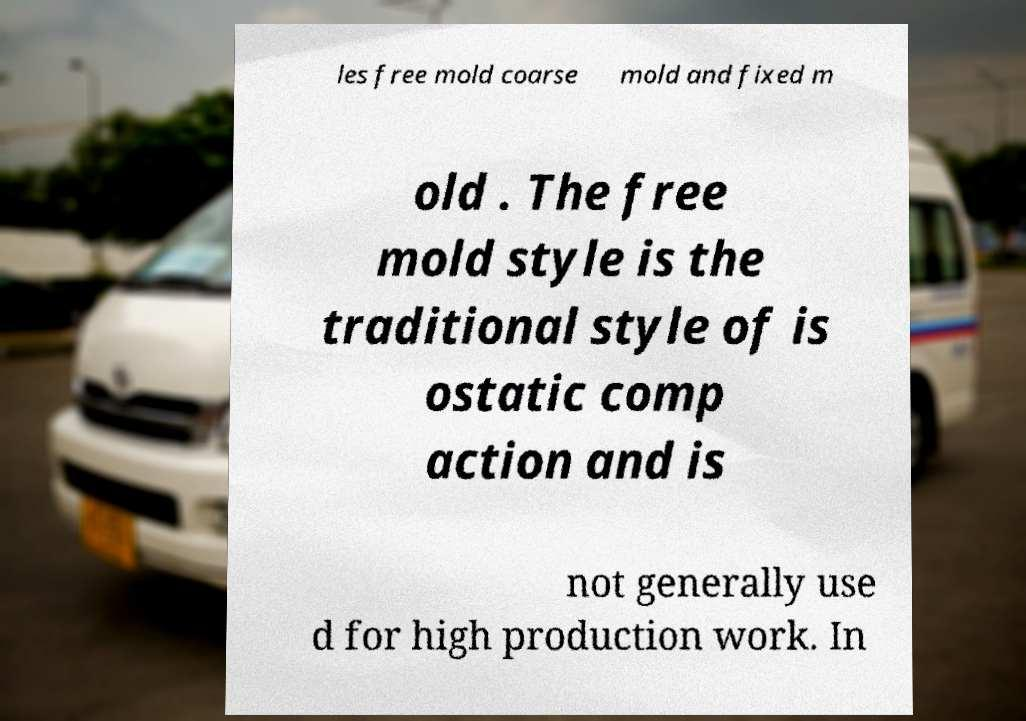Please read and relay the text visible in this image. What does it say? les free mold coarse mold and fixed m old . The free mold style is the traditional style of is ostatic comp action and is not generally use d for high production work. In 